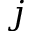<formula> <loc_0><loc_0><loc_500><loc_500>j</formula> 